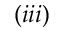<formula> <loc_0><loc_0><loc_500><loc_500>( i i i )</formula> 